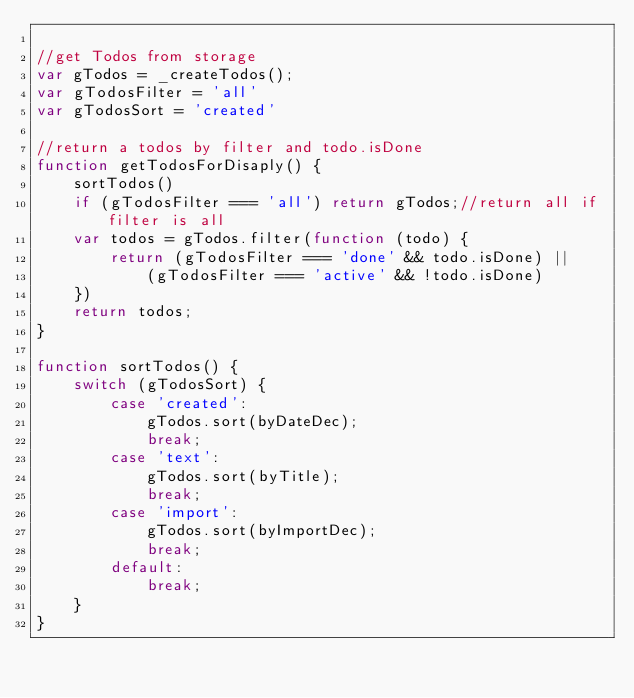Convert code to text. <code><loc_0><loc_0><loc_500><loc_500><_JavaScript_>
//get Todos from storage
var gTodos = _createTodos();
var gTodosFilter = 'all'
var gTodosSort = 'created'

//return a todos by filter and todo.isDone
function getTodosForDisaply() {
    sortTodos()
    if (gTodosFilter === 'all') return gTodos;//return all if filter is all
    var todos = gTodos.filter(function (todo) {
        return (gTodosFilter === 'done' && todo.isDone) ||
            (gTodosFilter === 'active' && !todo.isDone)
    })
    return todos;
}

function sortTodos() {
    switch (gTodosSort) {
        case 'created':
            gTodos.sort(byDateDec);
            break;
        case 'text':
            gTodos.sort(byTitle);
            break;
        case 'import':
            gTodos.sort(byImportDec);
            break;
        default:
            break;
    }
}
</code> 